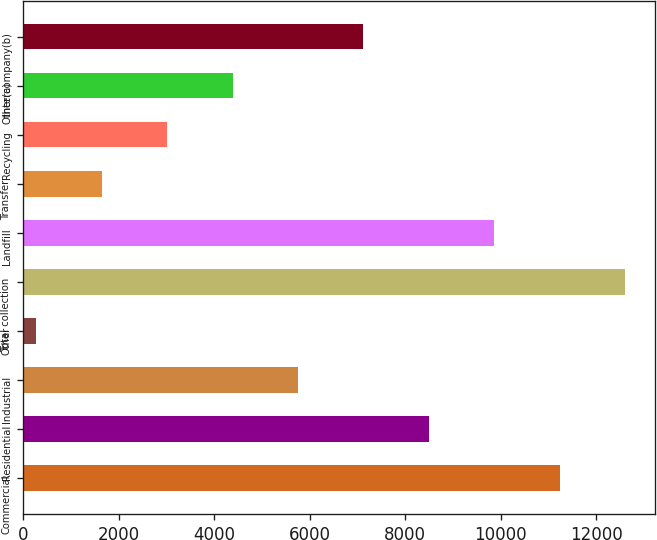Convert chart. <chart><loc_0><loc_0><loc_500><loc_500><bar_chart><fcel>Commercial<fcel>Residential<fcel>Industrial<fcel>Other<fcel>Total collection<fcel>Landfill<fcel>Transfer<fcel>Recycling<fcel>Other(a)<fcel>Intercompany(b)<nl><fcel>11241<fcel>8499<fcel>5757<fcel>273<fcel>12612<fcel>9870<fcel>1644<fcel>3015<fcel>4386<fcel>7128<nl></chart> 